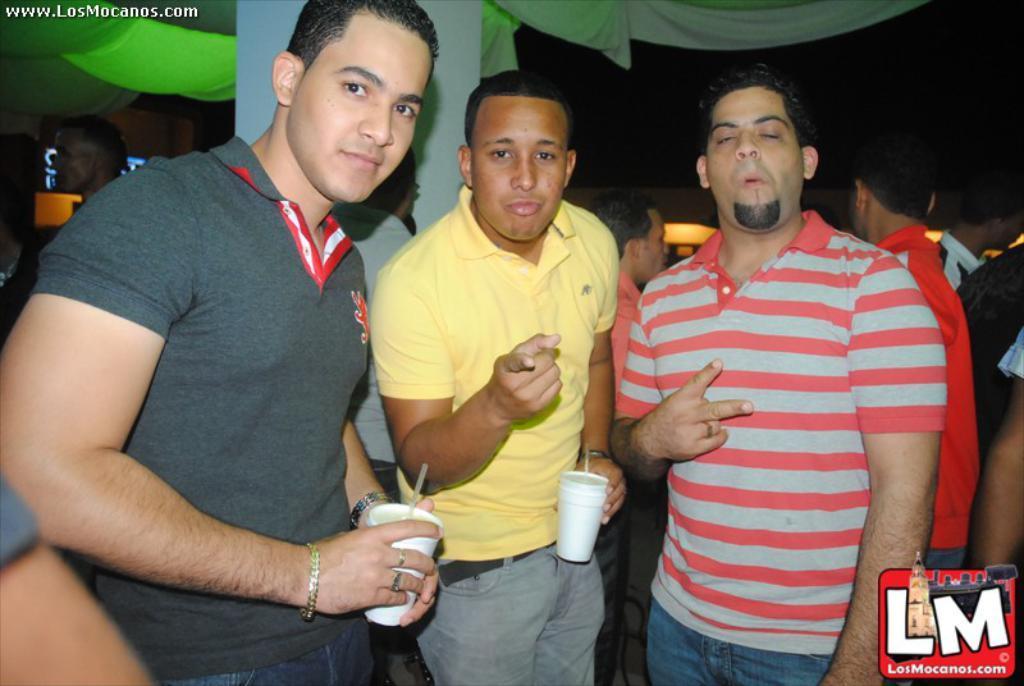Could you give a brief overview of what you see in this image? At the top and bottom portion of the picture we can see watermarks. In the background we can see the people and few objects. In this picture we can see the men wearing t-shirts and among them two men are holding glasses in their hands. We can see drinking straws in the glasses. They are giving a pose. 